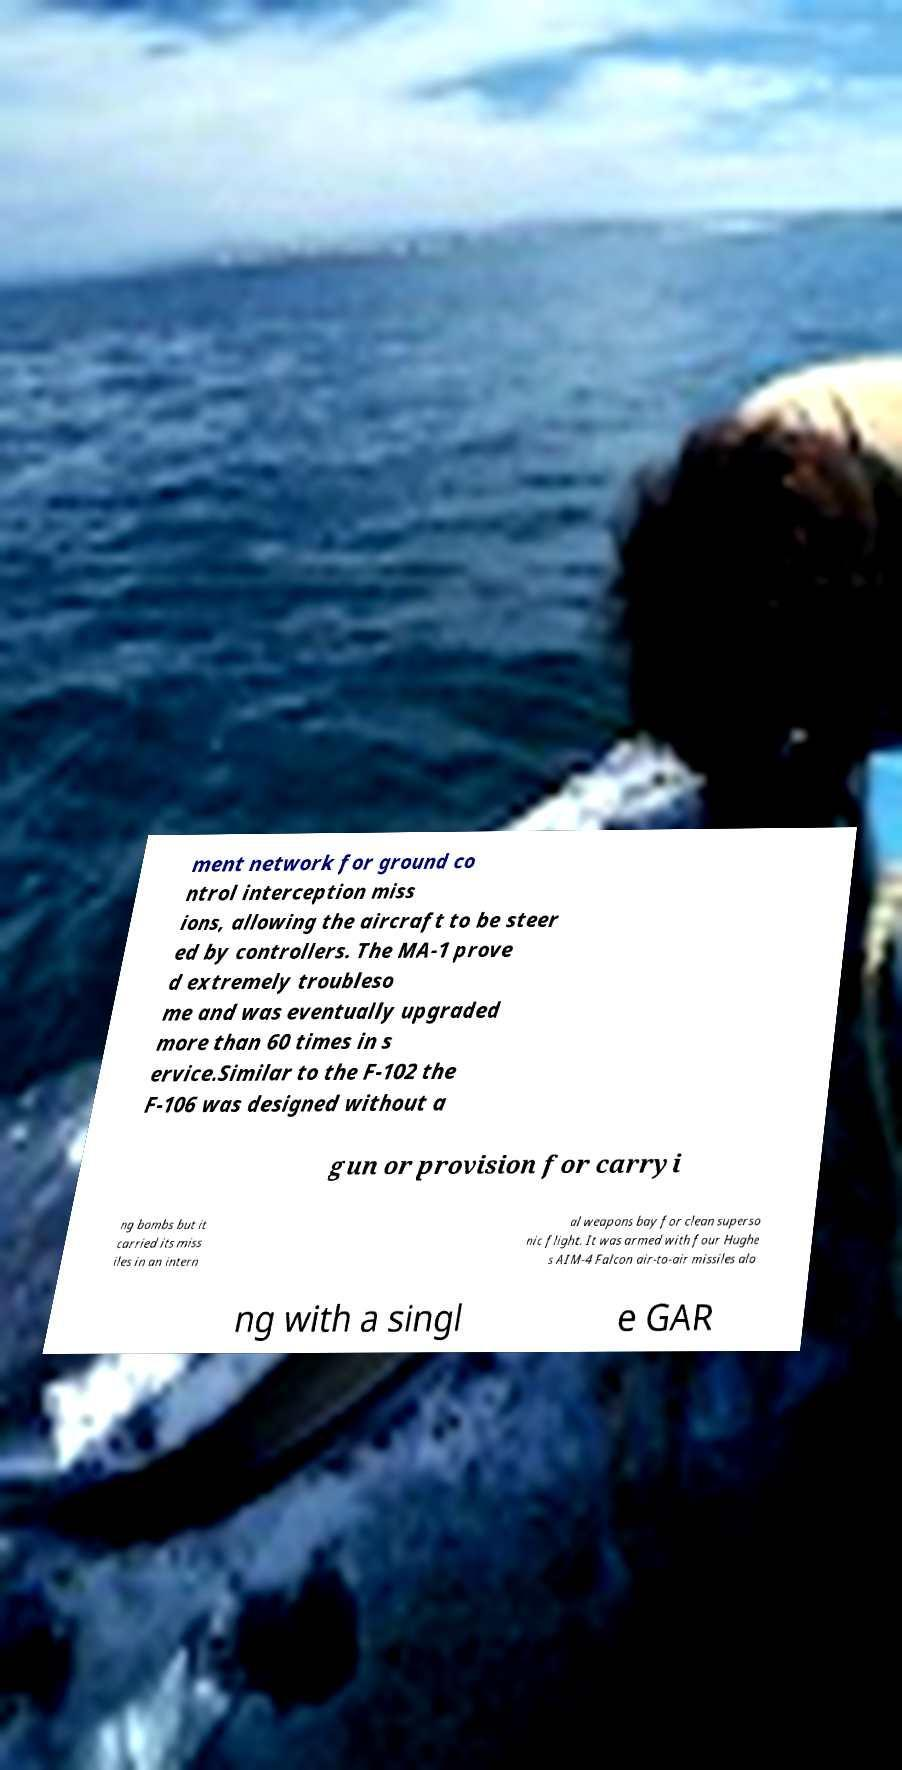Please read and relay the text visible in this image. What does it say? ment network for ground co ntrol interception miss ions, allowing the aircraft to be steer ed by controllers. The MA-1 prove d extremely troubleso me and was eventually upgraded more than 60 times in s ervice.Similar to the F-102 the F-106 was designed without a gun or provision for carryi ng bombs but it carried its miss iles in an intern al weapons bay for clean superso nic flight. It was armed with four Hughe s AIM-4 Falcon air-to-air missiles alo ng with a singl e GAR 